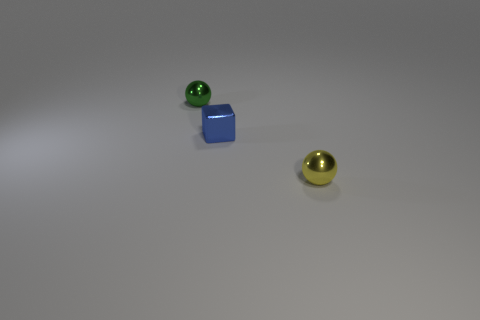Add 1 small blue objects. How many objects exist? 4 Subtract all balls. How many objects are left? 1 Add 3 green spheres. How many green spheres exist? 4 Subtract 0 red balls. How many objects are left? 3 Subtract all green things. Subtract all small cubes. How many objects are left? 1 Add 1 blue cubes. How many blue cubes are left? 2 